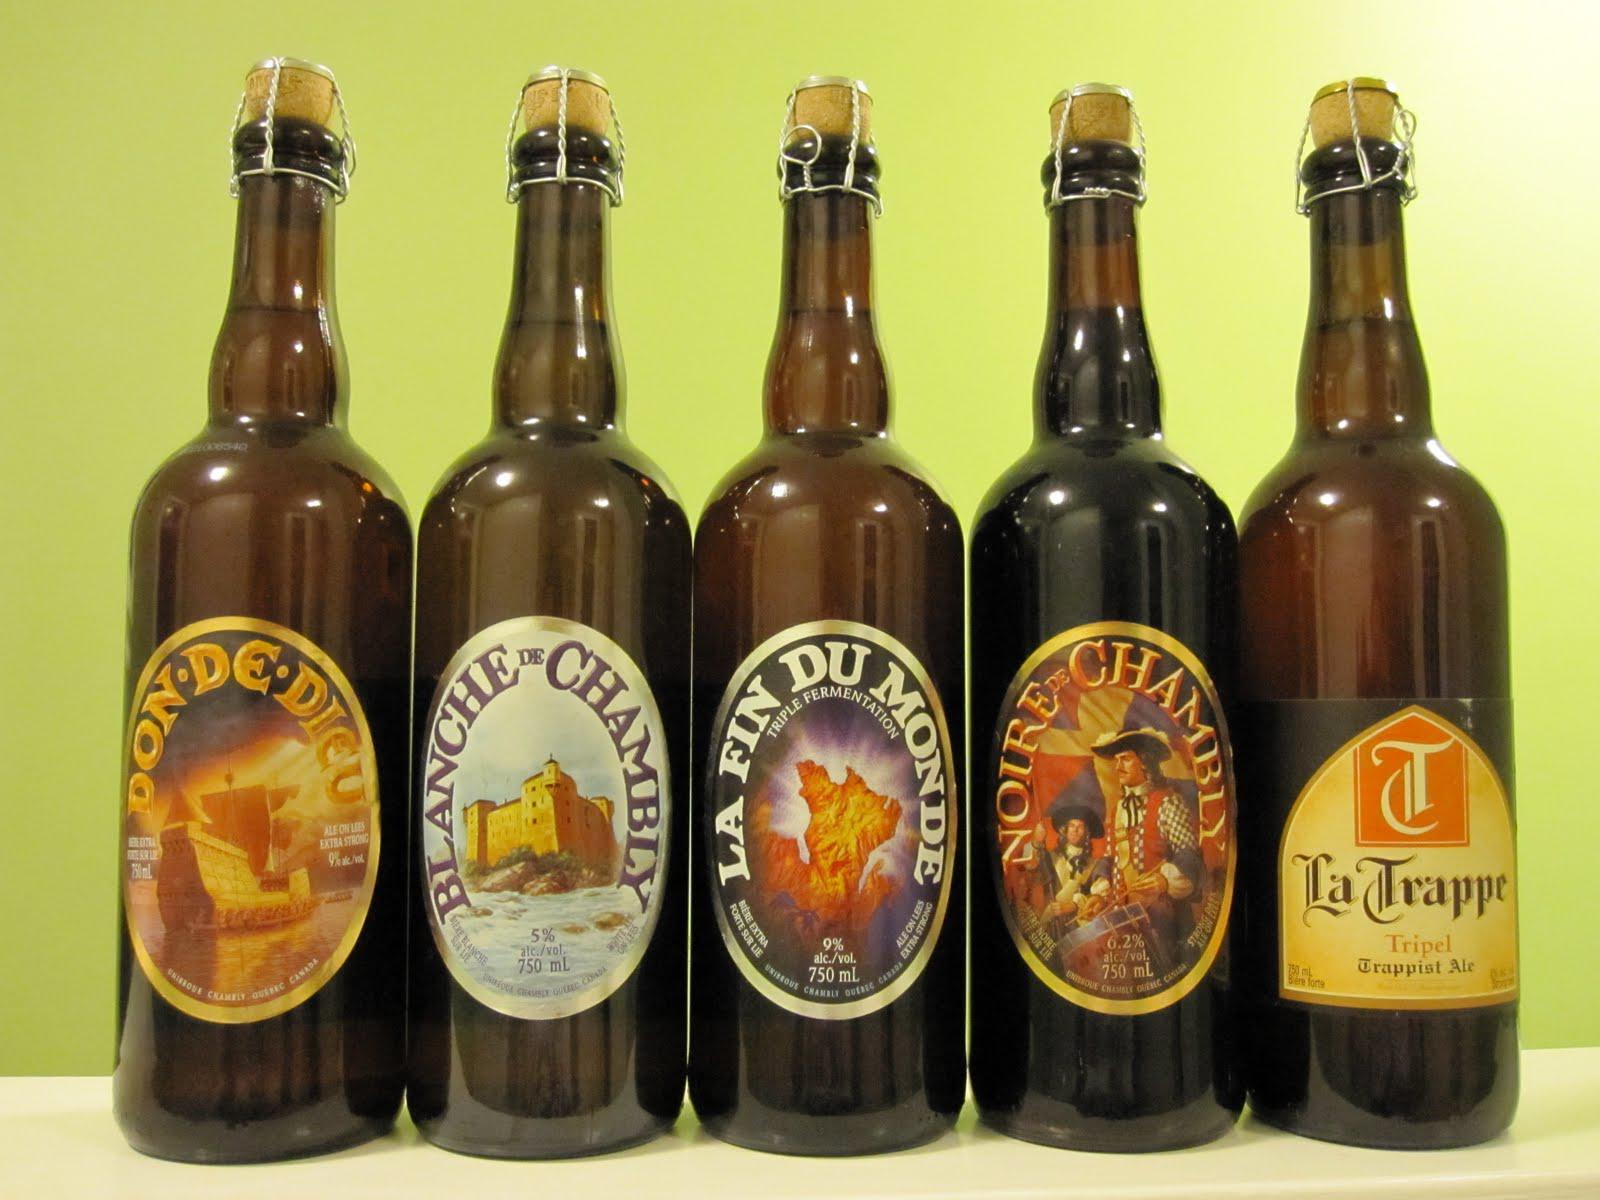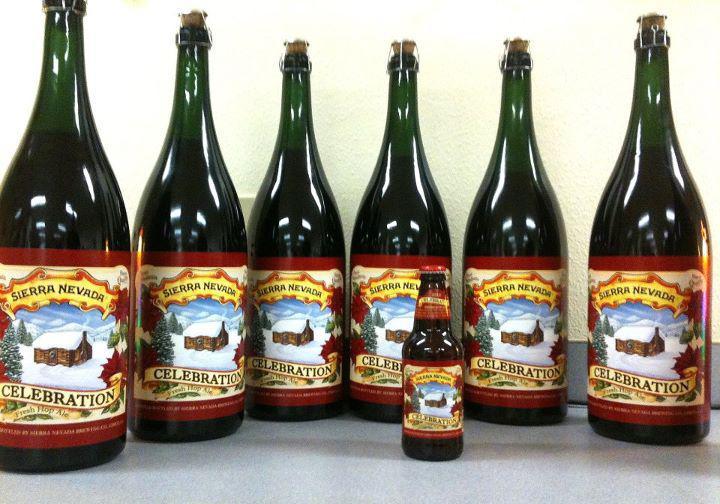The first image is the image on the left, the second image is the image on the right. Given the left and right images, does the statement "There are more bottles in the image on the right." hold true? Answer yes or no. Yes. The first image is the image on the left, the second image is the image on the right. For the images shown, is this caption "There is only one bottle in at least one of the images." true? Answer yes or no. No. 